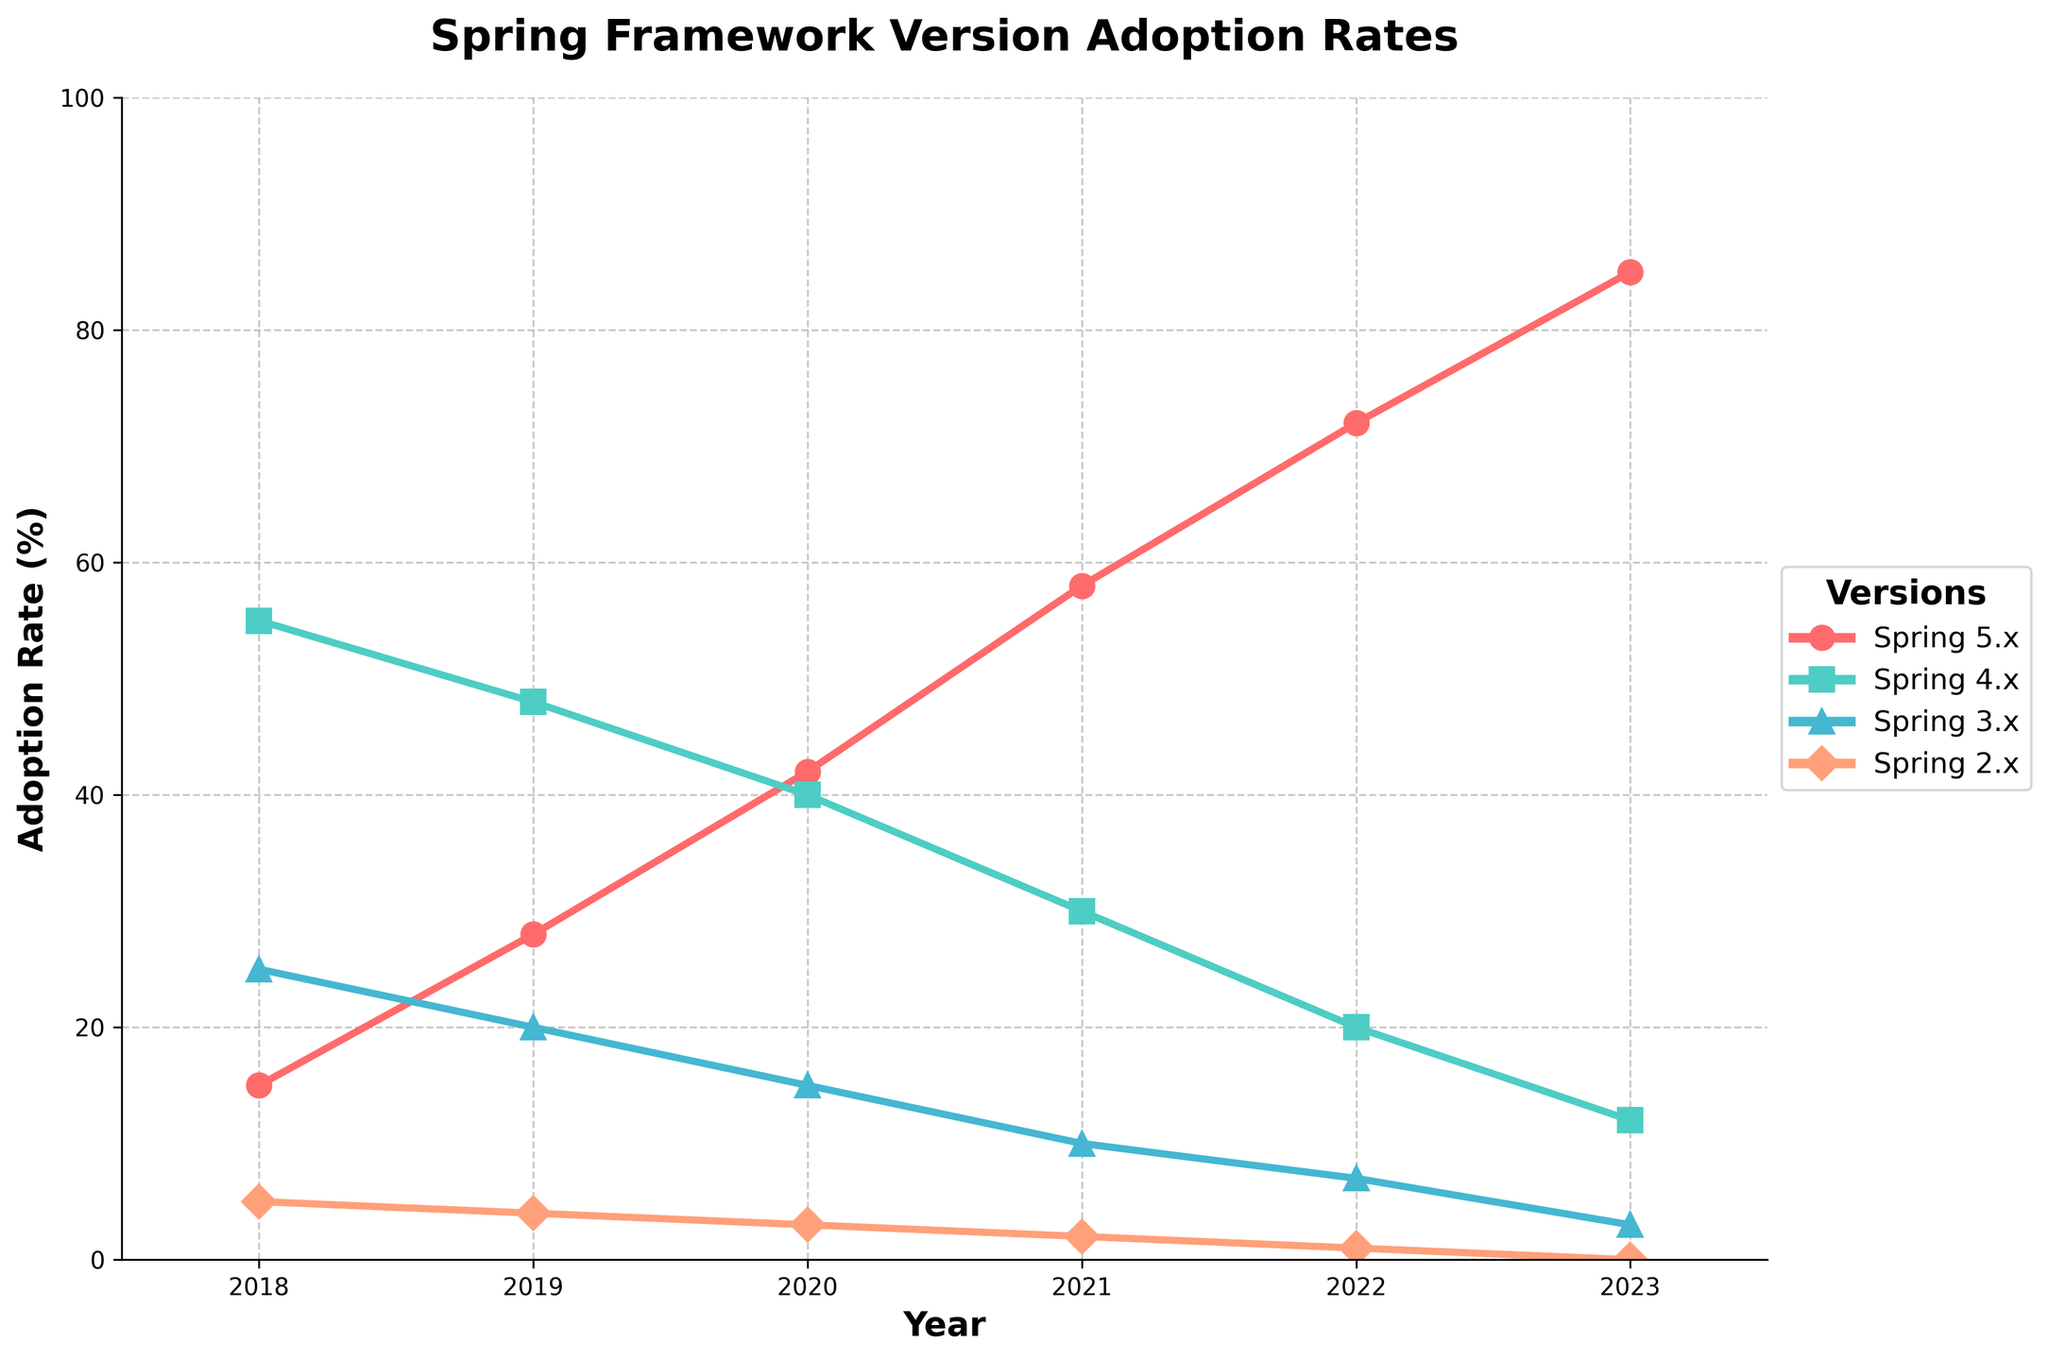What is the adoption rate of Spring 5.x in 2023? Look at the point corresponding to the year 2023 on the line representing Spring 5.x adoption rate.
Answer: 85% Which year saw the steepest increase in adoption rate for Spring 5.x? By comparing the differences in adoption rates year-to-year for Spring 5.x, the largest jump is seen from 2020 to 2021 (42% to 58%), which is an increase of 16 percentage points.
Answer: 2021 How does the adoption rate of Spring 4.x in 2022 compare to that in 2018? Subtract the 2022 value for Spring 4.x (20%) from the 2018 value (55%).
Answer: It decreased by 35 percentage points Which version has the lowest adoption rate in 2020, and what is it? Compare the adoption rates of all versions in 2020. Spring 2.x has the lowest rate at 3%.
Answer: Spring 2.x, 3% Calculate the average adoption rate of Spring 3.x from 2018 to 2023 inclusive. Sum the adoption rates for Spring 3.x over all years and divide by the number of years: (25 + 20 + 15 + 10 + 7 + 3) / 6 = 13.33%.
Answer: 13.33% Between which years does Spring 4.x show the highest rate of decline? Calculate the difference year-by-year for Spring 4.x and identify where the largest drop occurs. The largest decline is from 2021 (30%) to 2022 (20%), which is 10 percentage points.
Answer: 2021 to 2022 What is the total adoption rate of Spring 5.x and Spring 4.x in 2023? Add the 2023 adoption rates for Spring 5.x (85%) and Spring 4.x (12%).
Answer: 97% Which version had a consistent decline in adoption rate from 2018 to 2023? Spring 4.x shows a consistent decline as it reduces each consecutive year from 2018 to 2023.
Answer: Spring 4.x In which year did Spring 2.x reach its lowest adoption rate? It's clear from the plot that by 2023, Spring 2.x adoption rate dropped to 0%, which is its lowest.
Answer: 2023 How does the highest adoption rate of Spring 3.x compare to the highest adoption rate of Spring 4.x in any single year within the dataset? Spring 3.x reaches its highest at 25% in 2018, while Spring 4.x reaches its highest at 55% in 2018. Compare 25% to 55%.
Answer: Spring 4.x is 30 percentage points higher 